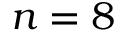Convert formula to latex. <formula><loc_0><loc_0><loc_500><loc_500>n = 8</formula> 